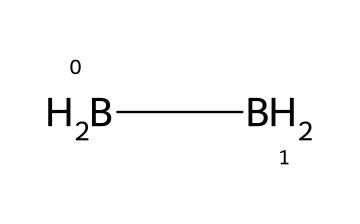How many boron atoms are in diborane? The SMILES representation shows two [B] symbols, indicating that there are two boron atoms present in the chemical structure.
Answer: two How many hydrogen atoms are in diborane? The SMILES representation includes two [H2] groups, and since each [H2] represents two hydrogen atoms linked to boron, we have a total of four hydrogen atoms in diborane.
Answer: four What is the geometry of diborane? Diborane is known to have a characteristic geometry of 3-dimensional shape, often referred to as 'banana' shaped due to its bridging hydrogens; it features a non-linear arrangement in space.
Answer: non-linear What type of bonds are present in diborane? Looking at the structure indicated by the SMILES, diborane contains B-H single bonds, as well as B-H-B bridges formed by two hydrogen atoms that connect two boron atoms.
Answer: single bonds and bridges What is a unique property of diborane compared to other boranes? Diborane is distinctive due to its ability to form B-H-B bridge structures, which is a unique characteristic not typically found in other boranes, making it reactive in various chemical environments.
Answer: bridging hydrogens How does diborane react with oxygen? Diborane reacts with oxygen through combustion, producing boron oxides and releasing energy, which highlights its reactivity with oxidizing agents.
Answer: combusts to form boron oxides 